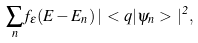<formula> <loc_0><loc_0><loc_500><loc_500>\sum _ { n } f _ { \epsilon } ( E - E _ { n } ) \, | \, < { q } | \psi _ { n } > \, | ^ { 2 } ,</formula> 